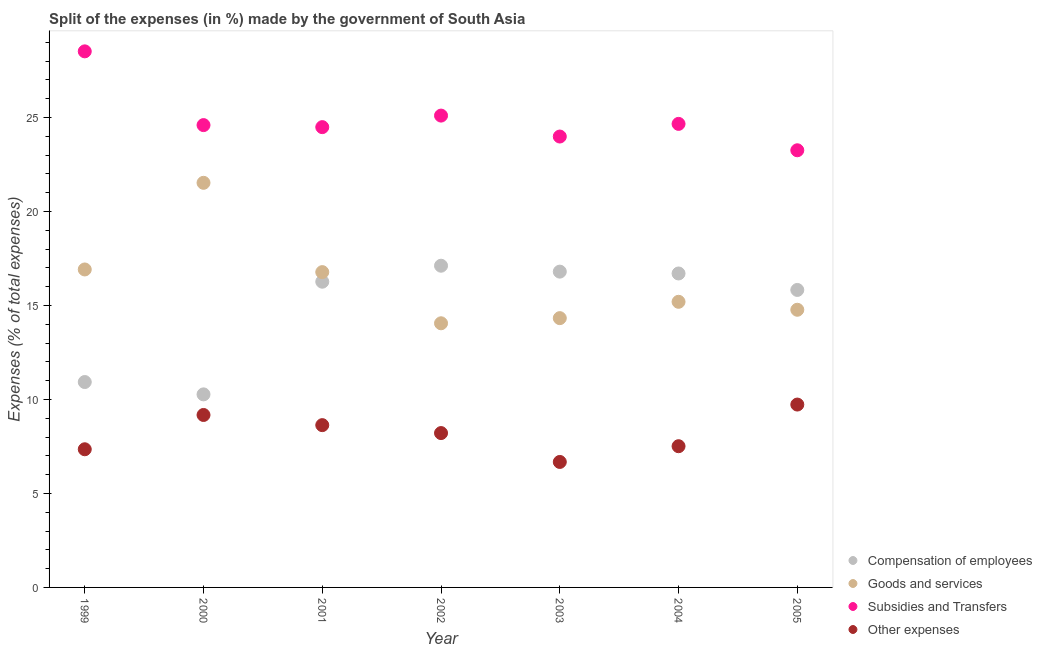Is the number of dotlines equal to the number of legend labels?
Offer a terse response. Yes. What is the percentage of amount spent on compensation of employees in 1999?
Make the answer very short. 10.93. Across all years, what is the maximum percentage of amount spent on other expenses?
Provide a succinct answer. 9.73. Across all years, what is the minimum percentage of amount spent on goods and services?
Offer a terse response. 14.05. In which year was the percentage of amount spent on compensation of employees maximum?
Give a very brief answer. 2002. In which year was the percentage of amount spent on other expenses minimum?
Ensure brevity in your answer.  2003. What is the total percentage of amount spent on other expenses in the graph?
Your response must be concise. 57.28. What is the difference between the percentage of amount spent on other expenses in 2001 and that in 2002?
Offer a terse response. 0.42. What is the difference between the percentage of amount spent on other expenses in 2003 and the percentage of amount spent on subsidies in 2005?
Provide a succinct answer. -16.58. What is the average percentage of amount spent on goods and services per year?
Give a very brief answer. 16.22. In the year 2005, what is the difference between the percentage of amount spent on other expenses and percentage of amount spent on goods and services?
Offer a terse response. -5.04. In how many years, is the percentage of amount spent on other expenses greater than 18 %?
Your answer should be compact. 0. What is the ratio of the percentage of amount spent on compensation of employees in 2003 to that in 2004?
Your response must be concise. 1.01. Is the percentage of amount spent on goods and services in 1999 less than that in 2001?
Provide a short and direct response. No. Is the difference between the percentage of amount spent on compensation of employees in 2004 and 2005 greater than the difference between the percentage of amount spent on goods and services in 2004 and 2005?
Your answer should be compact. Yes. What is the difference between the highest and the second highest percentage of amount spent on subsidies?
Your answer should be very brief. 3.42. What is the difference between the highest and the lowest percentage of amount spent on compensation of employees?
Provide a succinct answer. 6.84. In how many years, is the percentage of amount spent on compensation of employees greater than the average percentage of amount spent on compensation of employees taken over all years?
Ensure brevity in your answer.  5. Is the percentage of amount spent on goods and services strictly greater than the percentage of amount spent on subsidies over the years?
Your response must be concise. No. How many dotlines are there?
Provide a short and direct response. 4. How many years are there in the graph?
Make the answer very short. 7. Are the values on the major ticks of Y-axis written in scientific E-notation?
Ensure brevity in your answer.  No. Does the graph contain any zero values?
Offer a very short reply. No. Where does the legend appear in the graph?
Ensure brevity in your answer.  Bottom right. How are the legend labels stacked?
Make the answer very short. Vertical. What is the title of the graph?
Provide a short and direct response. Split of the expenses (in %) made by the government of South Asia. Does "European Union" appear as one of the legend labels in the graph?
Provide a short and direct response. No. What is the label or title of the X-axis?
Your response must be concise. Year. What is the label or title of the Y-axis?
Offer a very short reply. Expenses (% of total expenses). What is the Expenses (% of total expenses) of Compensation of employees in 1999?
Offer a very short reply. 10.93. What is the Expenses (% of total expenses) of Goods and services in 1999?
Offer a terse response. 16.91. What is the Expenses (% of total expenses) of Subsidies and Transfers in 1999?
Provide a short and direct response. 28.51. What is the Expenses (% of total expenses) in Other expenses in 1999?
Ensure brevity in your answer.  7.35. What is the Expenses (% of total expenses) in Compensation of employees in 2000?
Ensure brevity in your answer.  10.27. What is the Expenses (% of total expenses) in Goods and services in 2000?
Your answer should be very brief. 21.52. What is the Expenses (% of total expenses) of Subsidies and Transfers in 2000?
Give a very brief answer. 24.59. What is the Expenses (% of total expenses) of Other expenses in 2000?
Offer a very short reply. 9.17. What is the Expenses (% of total expenses) of Compensation of employees in 2001?
Offer a very short reply. 16.26. What is the Expenses (% of total expenses) in Goods and services in 2001?
Give a very brief answer. 16.77. What is the Expenses (% of total expenses) of Subsidies and Transfers in 2001?
Give a very brief answer. 24.48. What is the Expenses (% of total expenses) of Other expenses in 2001?
Your response must be concise. 8.63. What is the Expenses (% of total expenses) of Compensation of employees in 2002?
Give a very brief answer. 17.11. What is the Expenses (% of total expenses) of Goods and services in 2002?
Give a very brief answer. 14.05. What is the Expenses (% of total expenses) in Subsidies and Transfers in 2002?
Keep it short and to the point. 25.1. What is the Expenses (% of total expenses) in Other expenses in 2002?
Provide a succinct answer. 8.21. What is the Expenses (% of total expenses) of Compensation of employees in 2003?
Your response must be concise. 16.8. What is the Expenses (% of total expenses) of Goods and services in 2003?
Give a very brief answer. 14.32. What is the Expenses (% of total expenses) of Subsidies and Transfers in 2003?
Your answer should be compact. 23.98. What is the Expenses (% of total expenses) of Other expenses in 2003?
Offer a very short reply. 6.67. What is the Expenses (% of total expenses) in Compensation of employees in 2004?
Offer a terse response. 16.7. What is the Expenses (% of total expenses) in Goods and services in 2004?
Your response must be concise. 15.19. What is the Expenses (% of total expenses) of Subsidies and Transfers in 2004?
Make the answer very short. 24.66. What is the Expenses (% of total expenses) of Other expenses in 2004?
Your answer should be compact. 7.51. What is the Expenses (% of total expenses) in Compensation of employees in 2005?
Offer a terse response. 15.82. What is the Expenses (% of total expenses) of Goods and services in 2005?
Give a very brief answer. 14.77. What is the Expenses (% of total expenses) in Subsidies and Transfers in 2005?
Offer a very short reply. 23.25. What is the Expenses (% of total expenses) of Other expenses in 2005?
Offer a very short reply. 9.73. Across all years, what is the maximum Expenses (% of total expenses) of Compensation of employees?
Give a very brief answer. 17.11. Across all years, what is the maximum Expenses (% of total expenses) of Goods and services?
Offer a very short reply. 21.52. Across all years, what is the maximum Expenses (% of total expenses) in Subsidies and Transfers?
Make the answer very short. 28.51. Across all years, what is the maximum Expenses (% of total expenses) of Other expenses?
Offer a terse response. 9.73. Across all years, what is the minimum Expenses (% of total expenses) in Compensation of employees?
Provide a succinct answer. 10.27. Across all years, what is the minimum Expenses (% of total expenses) in Goods and services?
Provide a short and direct response. 14.05. Across all years, what is the minimum Expenses (% of total expenses) of Subsidies and Transfers?
Make the answer very short. 23.25. Across all years, what is the minimum Expenses (% of total expenses) of Other expenses?
Keep it short and to the point. 6.67. What is the total Expenses (% of total expenses) in Compensation of employees in the graph?
Offer a terse response. 103.89. What is the total Expenses (% of total expenses) in Goods and services in the graph?
Give a very brief answer. 113.54. What is the total Expenses (% of total expenses) of Subsidies and Transfers in the graph?
Your response must be concise. 174.58. What is the total Expenses (% of total expenses) of Other expenses in the graph?
Your answer should be very brief. 57.28. What is the difference between the Expenses (% of total expenses) of Compensation of employees in 1999 and that in 2000?
Provide a short and direct response. 0.66. What is the difference between the Expenses (% of total expenses) of Goods and services in 1999 and that in 2000?
Offer a terse response. -4.61. What is the difference between the Expenses (% of total expenses) in Subsidies and Transfers in 1999 and that in 2000?
Your answer should be very brief. 3.92. What is the difference between the Expenses (% of total expenses) of Other expenses in 1999 and that in 2000?
Ensure brevity in your answer.  -1.82. What is the difference between the Expenses (% of total expenses) in Compensation of employees in 1999 and that in 2001?
Provide a succinct answer. -5.34. What is the difference between the Expenses (% of total expenses) of Goods and services in 1999 and that in 2001?
Ensure brevity in your answer.  0.14. What is the difference between the Expenses (% of total expenses) in Subsidies and Transfers in 1999 and that in 2001?
Offer a very short reply. 4.03. What is the difference between the Expenses (% of total expenses) in Other expenses in 1999 and that in 2001?
Offer a terse response. -1.28. What is the difference between the Expenses (% of total expenses) in Compensation of employees in 1999 and that in 2002?
Your answer should be very brief. -6.19. What is the difference between the Expenses (% of total expenses) in Goods and services in 1999 and that in 2002?
Provide a succinct answer. 2.86. What is the difference between the Expenses (% of total expenses) of Subsidies and Transfers in 1999 and that in 2002?
Make the answer very short. 3.42. What is the difference between the Expenses (% of total expenses) in Other expenses in 1999 and that in 2002?
Give a very brief answer. -0.86. What is the difference between the Expenses (% of total expenses) of Compensation of employees in 1999 and that in 2003?
Provide a succinct answer. -5.87. What is the difference between the Expenses (% of total expenses) in Goods and services in 1999 and that in 2003?
Your response must be concise. 2.59. What is the difference between the Expenses (% of total expenses) in Subsidies and Transfers in 1999 and that in 2003?
Make the answer very short. 4.53. What is the difference between the Expenses (% of total expenses) in Other expenses in 1999 and that in 2003?
Provide a succinct answer. 0.67. What is the difference between the Expenses (% of total expenses) of Compensation of employees in 1999 and that in 2004?
Your answer should be compact. -5.77. What is the difference between the Expenses (% of total expenses) of Goods and services in 1999 and that in 2004?
Your response must be concise. 1.72. What is the difference between the Expenses (% of total expenses) of Subsidies and Transfers in 1999 and that in 2004?
Your response must be concise. 3.86. What is the difference between the Expenses (% of total expenses) of Other expenses in 1999 and that in 2004?
Ensure brevity in your answer.  -0.16. What is the difference between the Expenses (% of total expenses) of Compensation of employees in 1999 and that in 2005?
Ensure brevity in your answer.  -4.9. What is the difference between the Expenses (% of total expenses) of Goods and services in 1999 and that in 2005?
Make the answer very short. 2.14. What is the difference between the Expenses (% of total expenses) in Subsidies and Transfers in 1999 and that in 2005?
Your answer should be compact. 5.26. What is the difference between the Expenses (% of total expenses) of Other expenses in 1999 and that in 2005?
Offer a very short reply. -2.38. What is the difference between the Expenses (% of total expenses) of Compensation of employees in 2000 and that in 2001?
Provide a short and direct response. -5.99. What is the difference between the Expenses (% of total expenses) of Goods and services in 2000 and that in 2001?
Provide a short and direct response. 4.75. What is the difference between the Expenses (% of total expenses) of Subsidies and Transfers in 2000 and that in 2001?
Offer a terse response. 0.11. What is the difference between the Expenses (% of total expenses) in Other expenses in 2000 and that in 2001?
Offer a terse response. 0.54. What is the difference between the Expenses (% of total expenses) in Compensation of employees in 2000 and that in 2002?
Provide a short and direct response. -6.84. What is the difference between the Expenses (% of total expenses) in Goods and services in 2000 and that in 2002?
Provide a short and direct response. 7.47. What is the difference between the Expenses (% of total expenses) of Subsidies and Transfers in 2000 and that in 2002?
Your answer should be very brief. -0.51. What is the difference between the Expenses (% of total expenses) of Other expenses in 2000 and that in 2002?
Provide a succinct answer. 0.96. What is the difference between the Expenses (% of total expenses) in Compensation of employees in 2000 and that in 2003?
Your response must be concise. -6.53. What is the difference between the Expenses (% of total expenses) in Goods and services in 2000 and that in 2003?
Make the answer very short. 7.2. What is the difference between the Expenses (% of total expenses) in Subsidies and Transfers in 2000 and that in 2003?
Provide a succinct answer. 0.61. What is the difference between the Expenses (% of total expenses) in Other expenses in 2000 and that in 2003?
Give a very brief answer. 2.5. What is the difference between the Expenses (% of total expenses) in Compensation of employees in 2000 and that in 2004?
Make the answer very short. -6.43. What is the difference between the Expenses (% of total expenses) of Goods and services in 2000 and that in 2004?
Give a very brief answer. 6.33. What is the difference between the Expenses (% of total expenses) in Subsidies and Transfers in 2000 and that in 2004?
Your response must be concise. -0.06. What is the difference between the Expenses (% of total expenses) of Other expenses in 2000 and that in 2004?
Keep it short and to the point. 1.66. What is the difference between the Expenses (% of total expenses) in Compensation of employees in 2000 and that in 2005?
Provide a short and direct response. -5.55. What is the difference between the Expenses (% of total expenses) of Goods and services in 2000 and that in 2005?
Make the answer very short. 6.75. What is the difference between the Expenses (% of total expenses) in Subsidies and Transfers in 2000 and that in 2005?
Give a very brief answer. 1.34. What is the difference between the Expenses (% of total expenses) of Other expenses in 2000 and that in 2005?
Give a very brief answer. -0.55. What is the difference between the Expenses (% of total expenses) of Compensation of employees in 2001 and that in 2002?
Provide a succinct answer. -0.85. What is the difference between the Expenses (% of total expenses) of Goods and services in 2001 and that in 2002?
Your response must be concise. 2.72. What is the difference between the Expenses (% of total expenses) in Subsidies and Transfers in 2001 and that in 2002?
Provide a short and direct response. -0.61. What is the difference between the Expenses (% of total expenses) in Other expenses in 2001 and that in 2002?
Your response must be concise. 0.42. What is the difference between the Expenses (% of total expenses) in Compensation of employees in 2001 and that in 2003?
Give a very brief answer. -0.54. What is the difference between the Expenses (% of total expenses) in Goods and services in 2001 and that in 2003?
Keep it short and to the point. 2.45. What is the difference between the Expenses (% of total expenses) of Subsidies and Transfers in 2001 and that in 2003?
Make the answer very short. 0.5. What is the difference between the Expenses (% of total expenses) in Other expenses in 2001 and that in 2003?
Offer a very short reply. 1.96. What is the difference between the Expenses (% of total expenses) in Compensation of employees in 2001 and that in 2004?
Ensure brevity in your answer.  -0.44. What is the difference between the Expenses (% of total expenses) in Goods and services in 2001 and that in 2004?
Your answer should be compact. 1.58. What is the difference between the Expenses (% of total expenses) in Subsidies and Transfers in 2001 and that in 2004?
Your answer should be compact. -0.17. What is the difference between the Expenses (% of total expenses) of Other expenses in 2001 and that in 2004?
Your answer should be compact. 1.12. What is the difference between the Expenses (% of total expenses) in Compensation of employees in 2001 and that in 2005?
Give a very brief answer. 0.44. What is the difference between the Expenses (% of total expenses) of Goods and services in 2001 and that in 2005?
Your response must be concise. 2. What is the difference between the Expenses (% of total expenses) in Subsidies and Transfers in 2001 and that in 2005?
Your answer should be very brief. 1.23. What is the difference between the Expenses (% of total expenses) in Other expenses in 2001 and that in 2005?
Your answer should be compact. -1.09. What is the difference between the Expenses (% of total expenses) of Compensation of employees in 2002 and that in 2003?
Keep it short and to the point. 0.31. What is the difference between the Expenses (% of total expenses) of Goods and services in 2002 and that in 2003?
Your answer should be very brief. -0.27. What is the difference between the Expenses (% of total expenses) in Subsidies and Transfers in 2002 and that in 2003?
Make the answer very short. 1.11. What is the difference between the Expenses (% of total expenses) of Other expenses in 2002 and that in 2003?
Offer a very short reply. 1.54. What is the difference between the Expenses (% of total expenses) of Compensation of employees in 2002 and that in 2004?
Offer a very short reply. 0.41. What is the difference between the Expenses (% of total expenses) of Goods and services in 2002 and that in 2004?
Make the answer very short. -1.14. What is the difference between the Expenses (% of total expenses) of Subsidies and Transfers in 2002 and that in 2004?
Your answer should be very brief. 0.44. What is the difference between the Expenses (% of total expenses) in Other expenses in 2002 and that in 2004?
Give a very brief answer. 0.7. What is the difference between the Expenses (% of total expenses) in Compensation of employees in 2002 and that in 2005?
Provide a short and direct response. 1.29. What is the difference between the Expenses (% of total expenses) of Goods and services in 2002 and that in 2005?
Your answer should be compact. -0.72. What is the difference between the Expenses (% of total expenses) in Subsidies and Transfers in 2002 and that in 2005?
Your answer should be compact. 1.84. What is the difference between the Expenses (% of total expenses) in Other expenses in 2002 and that in 2005?
Ensure brevity in your answer.  -1.52. What is the difference between the Expenses (% of total expenses) in Compensation of employees in 2003 and that in 2004?
Ensure brevity in your answer.  0.1. What is the difference between the Expenses (% of total expenses) of Goods and services in 2003 and that in 2004?
Your answer should be compact. -0.87. What is the difference between the Expenses (% of total expenses) of Subsidies and Transfers in 2003 and that in 2004?
Ensure brevity in your answer.  -0.67. What is the difference between the Expenses (% of total expenses) of Other expenses in 2003 and that in 2004?
Make the answer very short. -0.84. What is the difference between the Expenses (% of total expenses) of Compensation of employees in 2003 and that in 2005?
Offer a terse response. 0.97. What is the difference between the Expenses (% of total expenses) of Goods and services in 2003 and that in 2005?
Give a very brief answer. -0.45. What is the difference between the Expenses (% of total expenses) in Subsidies and Transfers in 2003 and that in 2005?
Your answer should be very brief. 0.73. What is the difference between the Expenses (% of total expenses) in Other expenses in 2003 and that in 2005?
Offer a very short reply. -3.05. What is the difference between the Expenses (% of total expenses) in Compensation of employees in 2004 and that in 2005?
Provide a short and direct response. 0.88. What is the difference between the Expenses (% of total expenses) in Goods and services in 2004 and that in 2005?
Offer a terse response. 0.42. What is the difference between the Expenses (% of total expenses) of Subsidies and Transfers in 2004 and that in 2005?
Your answer should be very brief. 1.4. What is the difference between the Expenses (% of total expenses) of Other expenses in 2004 and that in 2005?
Provide a succinct answer. -2.22. What is the difference between the Expenses (% of total expenses) of Compensation of employees in 1999 and the Expenses (% of total expenses) of Goods and services in 2000?
Your answer should be compact. -10.6. What is the difference between the Expenses (% of total expenses) of Compensation of employees in 1999 and the Expenses (% of total expenses) of Subsidies and Transfers in 2000?
Ensure brevity in your answer.  -13.67. What is the difference between the Expenses (% of total expenses) of Compensation of employees in 1999 and the Expenses (% of total expenses) of Other expenses in 2000?
Your answer should be compact. 1.75. What is the difference between the Expenses (% of total expenses) of Goods and services in 1999 and the Expenses (% of total expenses) of Subsidies and Transfers in 2000?
Make the answer very short. -7.68. What is the difference between the Expenses (% of total expenses) of Goods and services in 1999 and the Expenses (% of total expenses) of Other expenses in 2000?
Give a very brief answer. 7.74. What is the difference between the Expenses (% of total expenses) in Subsidies and Transfers in 1999 and the Expenses (% of total expenses) in Other expenses in 2000?
Make the answer very short. 19.34. What is the difference between the Expenses (% of total expenses) of Compensation of employees in 1999 and the Expenses (% of total expenses) of Goods and services in 2001?
Your response must be concise. -5.85. What is the difference between the Expenses (% of total expenses) of Compensation of employees in 1999 and the Expenses (% of total expenses) of Subsidies and Transfers in 2001?
Provide a short and direct response. -13.56. What is the difference between the Expenses (% of total expenses) in Compensation of employees in 1999 and the Expenses (% of total expenses) in Other expenses in 2001?
Your response must be concise. 2.29. What is the difference between the Expenses (% of total expenses) in Goods and services in 1999 and the Expenses (% of total expenses) in Subsidies and Transfers in 2001?
Offer a very short reply. -7.57. What is the difference between the Expenses (% of total expenses) in Goods and services in 1999 and the Expenses (% of total expenses) in Other expenses in 2001?
Your response must be concise. 8.28. What is the difference between the Expenses (% of total expenses) of Subsidies and Transfers in 1999 and the Expenses (% of total expenses) of Other expenses in 2001?
Provide a succinct answer. 19.88. What is the difference between the Expenses (% of total expenses) of Compensation of employees in 1999 and the Expenses (% of total expenses) of Goods and services in 2002?
Offer a terse response. -3.12. What is the difference between the Expenses (% of total expenses) in Compensation of employees in 1999 and the Expenses (% of total expenses) in Subsidies and Transfers in 2002?
Your answer should be very brief. -14.17. What is the difference between the Expenses (% of total expenses) of Compensation of employees in 1999 and the Expenses (% of total expenses) of Other expenses in 2002?
Your response must be concise. 2.72. What is the difference between the Expenses (% of total expenses) in Goods and services in 1999 and the Expenses (% of total expenses) in Subsidies and Transfers in 2002?
Offer a terse response. -8.18. What is the difference between the Expenses (% of total expenses) of Goods and services in 1999 and the Expenses (% of total expenses) of Other expenses in 2002?
Your response must be concise. 8.7. What is the difference between the Expenses (% of total expenses) of Subsidies and Transfers in 1999 and the Expenses (% of total expenses) of Other expenses in 2002?
Give a very brief answer. 20.3. What is the difference between the Expenses (% of total expenses) in Compensation of employees in 1999 and the Expenses (% of total expenses) in Goods and services in 2003?
Provide a short and direct response. -3.4. What is the difference between the Expenses (% of total expenses) of Compensation of employees in 1999 and the Expenses (% of total expenses) of Subsidies and Transfers in 2003?
Your answer should be very brief. -13.06. What is the difference between the Expenses (% of total expenses) of Compensation of employees in 1999 and the Expenses (% of total expenses) of Other expenses in 2003?
Give a very brief answer. 4.25. What is the difference between the Expenses (% of total expenses) of Goods and services in 1999 and the Expenses (% of total expenses) of Subsidies and Transfers in 2003?
Make the answer very short. -7.07. What is the difference between the Expenses (% of total expenses) of Goods and services in 1999 and the Expenses (% of total expenses) of Other expenses in 2003?
Give a very brief answer. 10.24. What is the difference between the Expenses (% of total expenses) of Subsidies and Transfers in 1999 and the Expenses (% of total expenses) of Other expenses in 2003?
Offer a very short reply. 21.84. What is the difference between the Expenses (% of total expenses) of Compensation of employees in 1999 and the Expenses (% of total expenses) of Goods and services in 2004?
Give a very brief answer. -4.27. What is the difference between the Expenses (% of total expenses) in Compensation of employees in 1999 and the Expenses (% of total expenses) in Subsidies and Transfers in 2004?
Your answer should be very brief. -13.73. What is the difference between the Expenses (% of total expenses) in Compensation of employees in 1999 and the Expenses (% of total expenses) in Other expenses in 2004?
Your answer should be compact. 3.41. What is the difference between the Expenses (% of total expenses) of Goods and services in 1999 and the Expenses (% of total expenses) of Subsidies and Transfers in 2004?
Your answer should be very brief. -7.74. What is the difference between the Expenses (% of total expenses) in Goods and services in 1999 and the Expenses (% of total expenses) in Other expenses in 2004?
Give a very brief answer. 9.4. What is the difference between the Expenses (% of total expenses) in Subsidies and Transfers in 1999 and the Expenses (% of total expenses) in Other expenses in 2004?
Make the answer very short. 21. What is the difference between the Expenses (% of total expenses) of Compensation of employees in 1999 and the Expenses (% of total expenses) of Goods and services in 2005?
Your response must be concise. -3.84. What is the difference between the Expenses (% of total expenses) of Compensation of employees in 1999 and the Expenses (% of total expenses) of Subsidies and Transfers in 2005?
Provide a short and direct response. -12.33. What is the difference between the Expenses (% of total expenses) in Compensation of employees in 1999 and the Expenses (% of total expenses) in Other expenses in 2005?
Your answer should be compact. 1.2. What is the difference between the Expenses (% of total expenses) of Goods and services in 1999 and the Expenses (% of total expenses) of Subsidies and Transfers in 2005?
Your response must be concise. -6.34. What is the difference between the Expenses (% of total expenses) of Goods and services in 1999 and the Expenses (% of total expenses) of Other expenses in 2005?
Ensure brevity in your answer.  7.19. What is the difference between the Expenses (% of total expenses) of Subsidies and Transfers in 1999 and the Expenses (% of total expenses) of Other expenses in 2005?
Your response must be concise. 18.79. What is the difference between the Expenses (% of total expenses) in Compensation of employees in 2000 and the Expenses (% of total expenses) in Goods and services in 2001?
Provide a short and direct response. -6.5. What is the difference between the Expenses (% of total expenses) of Compensation of employees in 2000 and the Expenses (% of total expenses) of Subsidies and Transfers in 2001?
Provide a succinct answer. -14.21. What is the difference between the Expenses (% of total expenses) in Compensation of employees in 2000 and the Expenses (% of total expenses) in Other expenses in 2001?
Make the answer very short. 1.64. What is the difference between the Expenses (% of total expenses) of Goods and services in 2000 and the Expenses (% of total expenses) of Subsidies and Transfers in 2001?
Keep it short and to the point. -2.96. What is the difference between the Expenses (% of total expenses) of Goods and services in 2000 and the Expenses (% of total expenses) of Other expenses in 2001?
Your response must be concise. 12.89. What is the difference between the Expenses (% of total expenses) in Subsidies and Transfers in 2000 and the Expenses (% of total expenses) in Other expenses in 2001?
Your answer should be very brief. 15.96. What is the difference between the Expenses (% of total expenses) of Compensation of employees in 2000 and the Expenses (% of total expenses) of Goods and services in 2002?
Provide a succinct answer. -3.78. What is the difference between the Expenses (% of total expenses) in Compensation of employees in 2000 and the Expenses (% of total expenses) in Subsidies and Transfers in 2002?
Give a very brief answer. -14.83. What is the difference between the Expenses (% of total expenses) in Compensation of employees in 2000 and the Expenses (% of total expenses) in Other expenses in 2002?
Keep it short and to the point. 2.06. What is the difference between the Expenses (% of total expenses) in Goods and services in 2000 and the Expenses (% of total expenses) in Subsidies and Transfers in 2002?
Provide a short and direct response. -3.58. What is the difference between the Expenses (% of total expenses) of Goods and services in 2000 and the Expenses (% of total expenses) of Other expenses in 2002?
Provide a succinct answer. 13.31. What is the difference between the Expenses (% of total expenses) in Subsidies and Transfers in 2000 and the Expenses (% of total expenses) in Other expenses in 2002?
Your response must be concise. 16.38. What is the difference between the Expenses (% of total expenses) in Compensation of employees in 2000 and the Expenses (% of total expenses) in Goods and services in 2003?
Provide a succinct answer. -4.05. What is the difference between the Expenses (% of total expenses) in Compensation of employees in 2000 and the Expenses (% of total expenses) in Subsidies and Transfers in 2003?
Your answer should be compact. -13.71. What is the difference between the Expenses (% of total expenses) in Compensation of employees in 2000 and the Expenses (% of total expenses) in Other expenses in 2003?
Your answer should be compact. 3.59. What is the difference between the Expenses (% of total expenses) in Goods and services in 2000 and the Expenses (% of total expenses) in Subsidies and Transfers in 2003?
Provide a succinct answer. -2.46. What is the difference between the Expenses (% of total expenses) in Goods and services in 2000 and the Expenses (% of total expenses) in Other expenses in 2003?
Your answer should be compact. 14.85. What is the difference between the Expenses (% of total expenses) in Subsidies and Transfers in 2000 and the Expenses (% of total expenses) in Other expenses in 2003?
Keep it short and to the point. 17.92. What is the difference between the Expenses (% of total expenses) of Compensation of employees in 2000 and the Expenses (% of total expenses) of Goods and services in 2004?
Provide a succinct answer. -4.92. What is the difference between the Expenses (% of total expenses) in Compensation of employees in 2000 and the Expenses (% of total expenses) in Subsidies and Transfers in 2004?
Make the answer very short. -14.39. What is the difference between the Expenses (% of total expenses) in Compensation of employees in 2000 and the Expenses (% of total expenses) in Other expenses in 2004?
Offer a very short reply. 2.76. What is the difference between the Expenses (% of total expenses) of Goods and services in 2000 and the Expenses (% of total expenses) of Subsidies and Transfers in 2004?
Make the answer very short. -3.14. What is the difference between the Expenses (% of total expenses) in Goods and services in 2000 and the Expenses (% of total expenses) in Other expenses in 2004?
Provide a succinct answer. 14.01. What is the difference between the Expenses (% of total expenses) of Subsidies and Transfers in 2000 and the Expenses (% of total expenses) of Other expenses in 2004?
Offer a terse response. 17.08. What is the difference between the Expenses (% of total expenses) in Compensation of employees in 2000 and the Expenses (% of total expenses) in Subsidies and Transfers in 2005?
Your response must be concise. -12.98. What is the difference between the Expenses (% of total expenses) of Compensation of employees in 2000 and the Expenses (% of total expenses) of Other expenses in 2005?
Your response must be concise. 0.54. What is the difference between the Expenses (% of total expenses) of Goods and services in 2000 and the Expenses (% of total expenses) of Subsidies and Transfers in 2005?
Keep it short and to the point. -1.73. What is the difference between the Expenses (% of total expenses) of Goods and services in 2000 and the Expenses (% of total expenses) of Other expenses in 2005?
Keep it short and to the point. 11.79. What is the difference between the Expenses (% of total expenses) of Subsidies and Transfers in 2000 and the Expenses (% of total expenses) of Other expenses in 2005?
Your answer should be compact. 14.86. What is the difference between the Expenses (% of total expenses) of Compensation of employees in 2001 and the Expenses (% of total expenses) of Goods and services in 2002?
Your answer should be compact. 2.21. What is the difference between the Expenses (% of total expenses) of Compensation of employees in 2001 and the Expenses (% of total expenses) of Subsidies and Transfers in 2002?
Your answer should be compact. -8.84. What is the difference between the Expenses (% of total expenses) in Compensation of employees in 2001 and the Expenses (% of total expenses) in Other expenses in 2002?
Provide a short and direct response. 8.05. What is the difference between the Expenses (% of total expenses) of Goods and services in 2001 and the Expenses (% of total expenses) of Subsidies and Transfers in 2002?
Provide a succinct answer. -8.33. What is the difference between the Expenses (% of total expenses) in Goods and services in 2001 and the Expenses (% of total expenses) in Other expenses in 2002?
Provide a short and direct response. 8.56. What is the difference between the Expenses (% of total expenses) in Subsidies and Transfers in 2001 and the Expenses (% of total expenses) in Other expenses in 2002?
Make the answer very short. 16.27. What is the difference between the Expenses (% of total expenses) in Compensation of employees in 2001 and the Expenses (% of total expenses) in Goods and services in 2003?
Your response must be concise. 1.94. What is the difference between the Expenses (% of total expenses) in Compensation of employees in 2001 and the Expenses (% of total expenses) in Subsidies and Transfers in 2003?
Offer a very short reply. -7.72. What is the difference between the Expenses (% of total expenses) in Compensation of employees in 2001 and the Expenses (% of total expenses) in Other expenses in 2003?
Ensure brevity in your answer.  9.59. What is the difference between the Expenses (% of total expenses) in Goods and services in 2001 and the Expenses (% of total expenses) in Subsidies and Transfers in 2003?
Ensure brevity in your answer.  -7.21. What is the difference between the Expenses (% of total expenses) of Goods and services in 2001 and the Expenses (% of total expenses) of Other expenses in 2003?
Provide a short and direct response. 10.1. What is the difference between the Expenses (% of total expenses) of Subsidies and Transfers in 2001 and the Expenses (% of total expenses) of Other expenses in 2003?
Offer a very short reply. 17.81. What is the difference between the Expenses (% of total expenses) of Compensation of employees in 2001 and the Expenses (% of total expenses) of Goods and services in 2004?
Keep it short and to the point. 1.07. What is the difference between the Expenses (% of total expenses) of Compensation of employees in 2001 and the Expenses (% of total expenses) of Subsidies and Transfers in 2004?
Give a very brief answer. -8.4. What is the difference between the Expenses (% of total expenses) in Compensation of employees in 2001 and the Expenses (% of total expenses) in Other expenses in 2004?
Ensure brevity in your answer.  8.75. What is the difference between the Expenses (% of total expenses) of Goods and services in 2001 and the Expenses (% of total expenses) of Subsidies and Transfers in 2004?
Provide a short and direct response. -7.89. What is the difference between the Expenses (% of total expenses) of Goods and services in 2001 and the Expenses (% of total expenses) of Other expenses in 2004?
Offer a very short reply. 9.26. What is the difference between the Expenses (% of total expenses) of Subsidies and Transfers in 2001 and the Expenses (% of total expenses) of Other expenses in 2004?
Provide a short and direct response. 16.97. What is the difference between the Expenses (% of total expenses) in Compensation of employees in 2001 and the Expenses (% of total expenses) in Goods and services in 2005?
Keep it short and to the point. 1.49. What is the difference between the Expenses (% of total expenses) in Compensation of employees in 2001 and the Expenses (% of total expenses) in Subsidies and Transfers in 2005?
Your answer should be very brief. -6.99. What is the difference between the Expenses (% of total expenses) of Compensation of employees in 2001 and the Expenses (% of total expenses) of Other expenses in 2005?
Keep it short and to the point. 6.53. What is the difference between the Expenses (% of total expenses) of Goods and services in 2001 and the Expenses (% of total expenses) of Subsidies and Transfers in 2005?
Offer a very short reply. -6.48. What is the difference between the Expenses (% of total expenses) in Goods and services in 2001 and the Expenses (% of total expenses) in Other expenses in 2005?
Provide a short and direct response. 7.04. What is the difference between the Expenses (% of total expenses) of Subsidies and Transfers in 2001 and the Expenses (% of total expenses) of Other expenses in 2005?
Your response must be concise. 14.76. What is the difference between the Expenses (% of total expenses) in Compensation of employees in 2002 and the Expenses (% of total expenses) in Goods and services in 2003?
Your answer should be very brief. 2.79. What is the difference between the Expenses (% of total expenses) in Compensation of employees in 2002 and the Expenses (% of total expenses) in Subsidies and Transfers in 2003?
Your answer should be compact. -6.87. What is the difference between the Expenses (% of total expenses) in Compensation of employees in 2002 and the Expenses (% of total expenses) in Other expenses in 2003?
Provide a succinct answer. 10.44. What is the difference between the Expenses (% of total expenses) in Goods and services in 2002 and the Expenses (% of total expenses) in Subsidies and Transfers in 2003?
Make the answer very short. -9.93. What is the difference between the Expenses (% of total expenses) of Goods and services in 2002 and the Expenses (% of total expenses) of Other expenses in 2003?
Your answer should be compact. 7.38. What is the difference between the Expenses (% of total expenses) in Subsidies and Transfers in 2002 and the Expenses (% of total expenses) in Other expenses in 2003?
Keep it short and to the point. 18.42. What is the difference between the Expenses (% of total expenses) of Compensation of employees in 2002 and the Expenses (% of total expenses) of Goods and services in 2004?
Offer a terse response. 1.92. What is the difference between the Expenses (% of total expenses) of Compensation of employees in 2002 and the Expenses (% of total expenses) of Subsidies and Transfers in 2004?
Provide a succinct answer. -7.54. What is the difference between the Expenses (% of total expenses) in Compensation of employees in 2002 and the Expenses (% of total expenses) in Other expenses in 2004?
Provide a short and direct response. 9.6. What is the difference between the Expenses (% of total expenses) of Goods and services in 2002 and the Expenses (% of total expenses) of Subsidies and Transfers in 2004?
Provide a succinct answer. -10.61. What is the difference between the Expenses (% of total expenses) of Goods and services in 2002 and the Expenses (% of total expenses) of Other expenses in 2004?
Ensure brevity in your answer.  6.54. What is the difference between the Expenses (% of total expenses) in Subsidies and Transfers in 2002 and the Expenses (% of total expenses) in Other expenses in 2004?
Your answer should be compact. 17.59. What is the difference between the Expenses (% of total expenses) in Compensation of employees in 2002 and the Expenses (% of total expenses) in Goods and services in 2005?
Your answer should be very brief. 2.34. What is the difference between the Expenses (% of total expenses) of Compensation of employees in 2002 and the Expenses (% of total expenses) of Subsidies and Transfers in 2005?
Keep it short and to the point. -6.14. What is the difference between the Expenses (% of total expenses) of Compensation of employees in 2002 and the Expenses (% of total expenses) of Other expenses in 2005?
Make the answer very short. 7.38. What is the difference between the Expenses (% of total expenses) of Goods and services in 2002 and the Expenses (% of total expenses) of Subsidies and Transfers in 2005?
Provide a succinct answer. -9.2. What is the difference between the Expenses (% of total expenses) in Goods and services in 2002 and the Expenses (% of total expenses) in Other expenses in 2005?
Your answer should be very brief. 4.32. What is the difference between the Expenses (% of total expenses) in Subsidies and Transfers in 2002 and the Expenses (% of total expenses) in Other expenses in 2005?
Keep it short and to the point. 15.37. What is the difference between the Expenses (% of total expenses) of Compensation of employees in 2003 and the Expenses (% of total expenses) of Goods and services in 2004?
Make the answer very short. 1.6. What is the difference between the Expenses (% of total expenses) of Compensation of employees in 2003 and the Expenses (% of total expenses) of Subsidies and Transfers in 2004?
Provide a short and direct response. -7.86. What is the difference between the Expenses (% of total expenses) in Compensation of employees in 2003 and the Expenses (% of total expenses) in Other expenses in 2004?
Provide a succinct answer. 9.29. What is the difference between the Expenses (% of total expenses) of Goods and services in 2003 and the Expenses (% of total expenses) of Subsidies and Transfers in 2004?
Your answer should be very brief. -10.33. What is the difference between the Expenses (% of total expenses) in Goods and services in 2003 and the Expenses (% of total expenses) in Other expenses in 2004?
Provide a short and direct response. 6.81. What is the difference between the Expenses (% of total expenses) of Subsidies and Transfers in 2003 and the Expenses (% of total expenses) of Other expenses in 2004?
Your response must be concise. 16.47. What is the difference between the Expenses (% of total expenses) in Compensation of employees in 2003 and the Expenses (% of total expenses) in Goods and services in 2005?
Your response must be concise. 2.03. What is the difference between the Expenses (% of total expenses) of Compensation of employees in 2003 and the Expenses (% of total expenses) of Subsidies and Transfers in 2005?
Ensure brevity in your answer.  -6.45. What is the difference between the Expenses (% of total expenses) in Compensation of employees in 2003 and the Expenses (% of total expenses) in Other expenses in 2005?
Make the answer very short. 7.07. What is the difference between the Expenses (% of total expenses) of Goods and services in 2003 and the Expenses (% of total expenses) of Subsidies and Transfers in 2005?
Ensure brevity in your answer.  -8.93. What is the difference between the Expenses (% of total expenses) in Goods and services in 2003 and the Expenses (% of total expenses) in Other expenses in 2005?
Your response must be concise. 4.6. What is the difference between the Expenses (% of total expenses) of Subsidies and Transfers in 2003 and the Expenses (% of total expenses) of Other expenses in 2005?
Keep it short and to the point. 14.26. What is the difference between the Expenses (% of total expenses) in Compensation of employees in 2004 and the Expenses (% of total expenses) in Goods and services in 2005?
Keep it short and to the point. 1.93. What is the difference between the Expenses (% of total expenses) of Compensation of employees in 2004 and the Expenses (% of total expenses) of Subsidies and Transfers in 2005?
Ensure brevity in your answer.  -6.55. What is the difference between the Expenses (% of total expenses) in Compensation of employees in 2004 and the Expenses (% of total expenses) in Other expenses in 2005?
Your response must be concise. 6.97. What is the difference between the Expenses (% of total expenses) of Goods and services in 2004 and the Expenses (% of total expenses) of Subsidies and Transfers in 2005?
Ensure brevity in your answer.  -8.06. What is the difference between the Expenses (% of total expenses) in Goods and services in 2004 and the Expenses (% of total expenses) in Other expenses in 2005?
Provide a short and direct response. 5.47. What is the difference between the Expenses (% of total expenses) of Subsidies and Transfers in 2004 and the Expenses (% of total expenses) of Other expenses in 2005?
Provide a succinct answer. 14.93. What is the average Expenses (% of total expenses) of Compensation of employees per year?
Offer a terse response. 14.84. What is the average Expenses (% of total expenses) in Goods and services per year?
Your response must be concise. 16.22. What is the average Expenses (% of total expenses) in Subsidies and Transfers per year?
Your answer should be very brief. 24.94. What is the average Expenses (% of total expenses) in Other expenses per year?
Offer a very short reply. 8.18. In the year 1999, what is the difference between the Expenses (% of total expenses) of Compensation of employees and Expenses (% of total expenses) of Goods and services?
Provide a short and direct response. -5.99. In the year 1999, what is the difference between the Expenses (% of total expenses) in Compensation of employees and Expenses (% of total expenses) in Subsidies and Transfers?
Provide a short and direct response. -17.59. In the year 1999, what is the difference between the Expenses (% of total expenses) in Compensation of employees and Expenses (% of total expenses) in Other expenses?
Keep it short and to the point. 3.58. In the year 1999, what is the difference between the Expenses (% of total expenses) in Goods and services and Expenses (% of total expenses) in Subsidies and Transfers?
Offer a terse response. -11.6. In the year 1999, what is the difference between the Expenses (% of total expenses) of Goods and services and Expenses (% of total expenses) of Other expenses?
Give a very brief answer. 9.56. In the year 1999, what is the difference between the Expenses (% of total expenses) of Subsidies and Transfers and Expenses (% of total expenses) of Other expenses?
Your answer should be very brief. 21.17. In the year 2000, what is the difference between the Expenses (% of total expenses) in Compensation of employees and Expenses (% of total expenses) in Goods and services?
Provide a succinct answer. -11.25. In the year 2000, what is the difference between the Expenses (% of total expenses) of Compensation of employees and Expenses (% of total expenses) of Subsidies and Transfers?
Give a very brief answer. -14.32. In the year 2000, what is the difference between the Expenses (% of total expenses) of Compensation of employees and Expenses (% of total expenses) of Other expenses?
Make the answer very short. 1.1. In the year 2000, what is the difference between the Expenses (% of total expenses) of Goods and services and Expenses (% of total expenses) of Subsidies and Transfers?
Your response must be concise. -3.07. In the year 2000, what is the difference between the Expenses (% of total expenses) in Goods and services and Expenses (% of total expenses) in Other expenses?
Your answer should be compact. 12.35. In the year 2000, what is the difference between the Expenses (% of total expenses) in Subsidies and Transfers and Expenses (% of total expenses) in Other expenses?
Give a very brief answer. 15.42. In the year 2001, what is the difference between the Expenses (% of total expenses) in Compensation of employees and Expenses (% of total expenses) in Goods and services?
Keep it short and to the point. -0.51. In the year 2001, what is the difference between the Expenses (% of total expenses) of Compensation of employees and Expenses (% of total expenses) of Subsidies and Transfers?
Keep it short and to the point. -8.22. In the year 2001, what is the difference between the Expenses (% of total expenses) in Compensation of employees and Expenses (% of total expenses) in Other expenses?
Offer a very short reply. 7.63. In the year 2001, what is the difference between the Expenses (% of total expenses) in Goods and services and Expenses (% of total expenses) in Subsidies and Transfers?
Offer a terse response. -7.71. In the year 2001, what is the difference between the Expenses (% of total expenses) in Goods and services and Expenses (% of total expenses) in Other expenses?
Ensure brevity in your answer.  8.14. In the year 2001, what is the difference between the Expenses (% of total expenses) in Subsidies and Transfers and Expenses (% of total expenses) in Other expenses?
Your answer should be compact. 15.85. In the year 2002, what is the difference between the Expenses (% of total expenses) of Compensation of employees and Expenses (% of total expenses) of Goods and services?
Your answer should be very brief. 3.06. In the year 2002, what is the difference between the Expenses (% of total expenses) of Compensation of employees and Expenses (% of total expenses) of Subsidies and Transfers?
Your response must be concise. -7.99. In the year 2002, what is the difference between the Expenses (% of total expenses) of Compensation of employees and Expenses (% of total expenses) of Other expenses?
Offer a very short reply. 8.9. In the year 2002, what is the difference between the Expenses (% of total expenses) of Goods and services and Expenses (% of total expenses) of Subsidies and Transfers?
Your answer should be very brief. -11.05. In the year 2002, what is the difference between the Expenses (% of total expenses) in Goods and services and Expenses (% of total expenses) in Other expenses?
Make the answer very short. 5.84. In the year 2002, what is the difference between the Expenses (% of total expenses) of Subsidies and Transfers and Expenses (% of total expenses) of Other expenses?
Give a very brief answer. 16.89. In the year 2003, what is the difference between the Expenses (% of total expenses) in Compensation of employees and Expenses (% of total expenses) in Goods and services?
Your answer should be very brief. 2.47. In the year 2003, what is the difference between the Expenses (% of total expenses) in Compensation of employees and Expenses (% of total expenses) in Subsidies and Transfers?
Provide a succinct answer. -7.19. In the year 2003, what is the difference between the Expenses (% of total expenses) of Compensation of employees and Expenses (% of total expenses) of Other expenses?
Provide a short and direct response. 10.12. In the year 2003, what is the difference between the Expenses (% of total expenses) of Goods and services and Expenses (% of total expenses) of Subsidies and Transfers?
Your response must be concise. -9.66. In the year 2003, what is the difference between the Expenses (% of total expenses) in Goods and services and Expenses (% of total expenses) in Other expenses?
Your response must be concise. 7.65. In the year 2003, what is the difference between the Expenses (% of total expenses) in Subsidies and Transfers and Expenses (% of total expenses) in Other expenses?
Ensure brevity in your answer.  17.31. In the year 2004, what is the difference between the Expenses (% of total expenses) in Compensation of employees and Expenses (% of total expenses) in Goods and services?
Make the answer very short. 1.51. In the year 2004, what is the difference between the Expenses (% of total expenses) in Compensation of employees and Expenses (% of total expenses) in Subsidies and Transfers?
Your response must be concise. -7.96. In the year 2004, what is the difference between the Expenses (% of total expenses) in Compensation of employees and Expenses (% of total expenses) in Other expenses?
Keep it short and to the point. 9.19. In the year 2004, what is the difference between the Expenses (% of total expenses) of Goods and services and Expenses (% of total expenses) of Subsidies and Transfers?
Your answer should be very brief. -9.46. In the year 2004, what is the difference between the Expenses (% of total expenses) in Goods and services and Expenses (% of total expenses) in Other expenses?
Your response must be concise. 7.68. In the year 2004, what is the difference between the Expenses (% of total expenses) in Subsidies and Transfers and Expenses (% of total expenses) in Other expenses?
Offer a terse response. 17.14. In the year 2005, what is the difference between the Expenses (% of total expenses) of Compensation of employees and Expenses (% of total expenses) of Goods and services?
Keep it short and to the point. 1.05. In the year 2005, what is the difference between the Expenses (% of total expenses) of Compensation of employees and Expenses (% of total expenses) of Subsidies and Transfers?
Your answer should be compact. -7.43. In the year 2005, what is the difference between the Expenses (% of total expenses) in Compensation of employees and Expenses (% of total expenses) in Other expenses?
Keep it short and to the point. 6.1. In the year 2005, what is the difference between the Expenses (% of total expenses) in Goods and services and Expenses (% of total expenses) in Subsidies and Transfers?
Give a very brief answer. -8.48. In the year 2005, what is the difference between the Expenses (% of total expenses) of Goods and services and Expenses (% of total expenses) of Other expenses?
Give a very brief answer. 5.04. In the year 2005, what is the difference between the Expenses (% of total expenses) in Subsidies and Transfers and Expenses (% of total expenses) in Other expenses?
Provide a short and direct response. 13.53. What is the ratio of the Expenses (% of total expenses) of Compensation of employees in 1999 to that in 2000?
Give a very brief answer. 1.06. What is the ratio of the Expenses (% of total expenses) of Goods and services in 1999 to that in 2000?
Provide a short and direct response. 0.79. What is the ratio of the Expenses (% of total expenses) in Subsidies and Transfers in 1999 to that in 2000?
Keep it short and to the point. 1.16. What is the ratio of the Expenses (% of total expenses) of Other expenses in 1999 to that in 2000?
Your answer should be very brief. 0.8. What is the ratio of the Expenses (% of total expenses) of Compensation of employees in 1999 to that in 2001?
Offer a very short reply. 0.67. What is the ratio of the Expenses (% of total expenses) of Goods and services in 1999 to that in 2001?
Ensure brevity in your answer.  1.01. What is the ratio of the Expenses (% of total expenses) of Subsidies and Transfers in 1999 to that in 2001?
Make the answer very short. 1.16. What is the ratio of the Expenses (% of total expenses) in Other expenses in 1999 to that in 2001?
Ensure brevity in your answer.  0.85. What is the ratio of the Expenses (% of total expenses) of Compensation of employees in 1999 to that in 2002?
Your response must be concise. 0.64. What is the ratio of the Expenses (% of total expenses) in Goods and services in 1999 to that in 2002?
Your answer should be very brief. 1.2. What is the ratio of the Expenses (% of total expenses) in Subsidies and Transfers in 1999 to that in 2002?
Offer a very short reply. 1.14. What is the ratio of the Expenses (% of total expenses) of Other expenses in 1999 to that in 2002?
Ensure brevity in your answer.  0.9. What is the ratio of the Expenses (% of total expenses) in Compensation of employees in 1999 to that in 2003?
Your answer should be very brief. 0.65. What is the ratio of the Expenses (% of total expenses) of Goods and services in 1999 to that in 2003?
Your response must be concise. 1.18. What is the ratio of the Expenses (% of total expenses) in Subsidies and Transfers in 1999 to that in 2003?
Make the answer very short. 1.19. What is the ratio of the Expenses (% of total expenses) of Other expenses in 1999 to that in 2003?
Your response must be concise. 1.1. What is the ratio of the Expenses (% of total expenses) in Compensation of employees in 1999 to that in 2004?
Your answer should be compact. 0.65. What is the ratio of the Expenses (% of total expenses) in Goods and services in 1999 to that in 2004?
Offer a very short reply. 1.11. What is the ratio of the Expenses (% of total expenses) in Subsidies and Transfers in 1999 to that in 2004?
Your response must be concise. 1.16. What is the ratio of the Expenses (% of total expenses) in Other expenses in 1999 to that in 2004?
Make the answer very short. 0.98. What is the ratio of the Expenses (% of total expenses) in Compensation of employees in 1999 to that in 2005?
Offer a very short reply. 0.69. What is the ratio of the Expenses (% of total expenses) in Goods and services in 1999 to that in 2005?
Your answer should be very brief. 1.15. What is the ratio of the Expenses (% of total expenses) of Subsidies and Transfers in 1999 to that in 2005?
Give a very brief answer. 1.23. What is the ratio of the Expenses (% of total expenses) in Other expenses in 1999 to that in 2005?
Make the answer very short. 0.76. What is the ratio of the Expenses (% of total expenses) of Compensation of employees in 2000 to that in 2001?
Ensure brevity in your answer.  0.63. What is the ratio of the Expenses (% of total expenses) in Goods and services in 2000 to that in 2001?
Offer a very short reply. 1.28. What is the ratio of the Expenses (% of total expenses) of Subsidies and Transfers in 2000 to that in 2001?
Ensure brevity in your answer.  1. What is the ratio of the Expenses (% of total expenses) of Other expenses in 2000 to that in 2001?
Your response must be concise. 1.06. What is the ratio of the Expenses (% of total expenses) in Compensation of employees in 2000 to that in 2002?
Make the answer very short. 0.6. What is the ratio of the Expenses (% of total expenses) in Goods and services in 2000 to that in 2002?
Your answer should be very brief. 1.53. What is the ratio of the Expenses (% of total expenses) of Subsidies and Transfers in 2000 to that in 2002?
Keep it short and to the point. 0.98. What is the ratio of the Expenses (% of total expenses) of Other expenses in 2000 to that in 2002?
Your answer should be very brief. 1.12. What is the ratio of the Expenses (% of total expenses) in Compensation of employees in 2000 to that in 2003?
Provide a succinct answer. 0.61. What is the ratio of the Expenses (% of total expenses) in Goods and services in 2000 to that in 2003?
Make the answer very short. 1.5. What is the ratio of the Expenses (% of total expenses) in Subsidies and Transfers in 2000 to that in 2003?
Offer a terse response. 1.03. What is the ratio of the Expenses (% of total expenses) in Other expenses in 2000 to that in 2003?
Ensure brevity in your answer.  1.37. What is the ratio of the Expenses (% of total expenses) of Compensation of employees in 2000 to that in 2004?
Make the answer very short. 0.61. What is the ratio of the Expenses (% of total expenses) in Goods and services in 2000 to that in 2004?
Provide a succinct answer. 1.42. What is the ratio of the Expenses (% of total expenses) of Other expenses in 2000 to that in 2004?
Provide a succinct answer. 1.22. What is the ratio of the Expenses (% of total expenses) of Compensation of employees in 2000 to that in 2005?
Give a very brief answer. 0.65. What is the ratio of the Expenses (% of total expenses) in Goods and services in 2000 to that in 2005?
Ensure brevity in your answer.  1.46. What is the ratio of the Expenses (% of total expenses) in Subsidies and Transfers in 2000 to that in 2005?
Your response must be concise. 1.06. What is the ratio of the Expenses (% of total expenses) of Other expenses in 2000 to that in 2005?
Your answer should be very brief. 0.94. What is the ratio of the Expenses (% of total expenses) in Compensation of employees in 2001 to that in 2002?
Provide a short and direct response. 0.95. What is the ratio of the Expenses (% of total expenses) in Goods and services in 2001 to that in 2002?
Your response must be concise. 1.19. What is the ratio of the Expenses (% of total expenses) in Subsidies and Transfers in 2001 to that in 2002?
Make the answer very short. 0.98. What is the ratio of the Expenses (% of total expenses) of Other expenses in 2001 to that in 2002?
Offer a very short reply. 1.05. What is the ratio of the Expenses (% of total expenses) in Compensation of employees in 2001 to that in 2003?
Provide a succinct answer. 0.97. What is the ratio of the Expenses (% of total expenses) in Goods and services in 2001 to that in 2003?
Make the answer very short. 1.17. What is the ratio of the Expenses (% of total expenses) in Subsidies and Transfers in 2001 to that in 2003?
Your answer should be very brief. 1.02. What is the ratio of the Expenses (% of total expenses) in Other expenses in 2001 to that in 2003?
Offer a very short reply. 1.29. What is the ratio of the Expenses (% of total expenses) of Compensation of employees in 2001 to that in 2004?
Your response must be concise. 0.97. What is the ratio of the Expenses (% of total expenses) in Goods and services in 2001 to that in 2004?
Provide a short and direct response. 1.1. What is the ratio of the Expenses (% of total expenses) of Subsidies and Transfers in 2001 to that in 2004?
Your answer should be very brief. 0.99. What is the ratio of the Expenses (% of total expenses) of Other expenses in 2001 to that in 2004?
Your answer should be very brief. 1.15. What is the ratio of the Expenses (% of total expenses) in Compensation of employees in 2001 to that in 2005?
Ensure brevity in your answer.  1.03. What is the ratio of the Expenses (% of total expenses) in Goods and services in 2001 to that in 2005?
Offer a terse response. 1.14. What is the ratio of the Expenses (% of total expenses) in Subsidies and Transfers in 2001 to that in 2005?
Ensure brevity in your answer.  1.05. What is the ratio of the Expenses (% of total expenses) of Other expenses in 2001 to that in 2005?
Your response must be concise. 0.89. What is the ratio of the Expenses (% of total expenses) in Compensation of employees in 2002 to that in 2003?
Ensure brevity in your answer.  1.02. What is the ratio of the Expenses (% of total expenses) of Goods and services in 2002 to that in 2003?
Provide a succinct answer. 0.98. What is the ratio of the Expenses (% of total expenses) in Subsidies and Transfers in 2002 to that in 2003?
Offer a very short reply. 1.05. What is the ratio of the Expenses (% of total expenses) of Other expenses in 2002 to that in 2003?
Offer a very short reply. 1.23. What is the ratio of the Expenses (% of total expenses) of Compensation of employees in 2002 to that in 2004?
Your answer should be compact. 1.02. What is the ratio of the Expenses (% of total expenses) in Goods and services in 2002 to that in 2004?
Give a very brief answer. 0.92. What is the ratio of the Expenses (% of total expenses) in Subsidies and Transfers in 2002 to that in 2004?
Give a very brief answer. 1.02. What is the ratio of the Expenses (% of total expenses) in Other expenses in 2002 to that in 2004?
Provide a succinct answer. 1.09. What is the ratio of the Expenses (% of total expenses) of Compensation of employees in 2002 to that in 2005?
Give a very brief answer. 1.08. What is the ratio of the Expenses (% of total expenses) of Goods and services in 2002 to that in 2005?
Provide a succinct answer. 0.95. What is the ratio of the Expenses (% of total expenses) in Subsidies and Transfers in 2002 to that in 2005?
Provide a succinct answer. 1.08. What is the ratio of the Expenses (% of total expenses) in Other expenses in 2002 to that in 2005?
Offer a very short reply. 0.84. What is the ratio of the Expenses (% of total expenses) of Compensation of employees in 2003 to that in 2004?
Provide a short and direct response. 1.01. What is the ratio of the Expenses (% of total expenses) of Goods and services in 2003 to that in 2004?
Offer a terse response. 0.94. What is the ratio of the Expenses (% of total expenses) of Subsidies and Transfers in 2003 to that in 2004?
Provide a short and direct response. 0.97. What is the ratio of the Expenses (% of total expenses) of Other expenses in 2003 to that in 2004?
Offer a terse response. 0.89. What is the ratio of the Expenses (% of total expenses) in Compensation of employees in 2003 to that in 2005?
Your answer should be compact. 1.06. What is the ratio of the Expenses (% of total expenses) of Goods and services in 2003 to that in 2005?
Provide a succinct answer. 0.97. What is the ratio of the Expenses (% of total expenses) of Subsidies and Transfers in 2003 to that in 2005?
Offer a very short reply. 1.03. What is the ratio of the Expenses (% of total expenses) in Other expenses in 2003 to that in 2005?
Provide a succinct answer. 0.69. What is the ratio of the Expenses (% of total expenses) of Compensation of employees in 2004 to that in 2005?
Provide a short and direct response. 1.06. What is the ratio of the Expenses (% of total expenses) of Goods and services in 2004 to that in 2005?
Your response must be concise. 1.03. What is the ratio of the Expenses (% of total expenses) of Subsidies and Transfers in 2004 to that in 2005?
Your answer should be very brief. 1.06. What is the ratio of the Expenses (% of total expenses) of Other expenses in 2004 to that in 2005?
Your answer should be very brief. 0.77. What is the difference between the highest and the second highest Expenses (% of total expenses) in Compensation of employees?
Offer a terse response. 0.31. What is the difference between the highest and the second highest Expenses (% of total expenses) of Goods and services?
Provide a short and direct response. 4.61. What is the difference between the highest and the second highest Expenses (% of total expenses) in Subsidies and Transfers?
Keep it short and to the point. 3.42. What is the difference between the highest and the second highest Expenses (% of total expenses) in Other expenses?
Keep it short and to the point. 0.55. What is the difference between the highest and the lowest Expenses (% of total expenses) in Compensation of employees?
Your answer should be very brief. 6.84. What is the difference between the highest and the lowest Expenses (% of total expenses) of Goods and services?
Offer a very short reply. 7.47. What is the difference between the highest and the lowest Expenses (% of total expenses) in Subsidies and Transfers?
Your answer should be compact. 5.26. What is the difference between the highest and the lowest Expenses (% of total expenses) in Other expenses?
Your response must be concise. 3.05. 